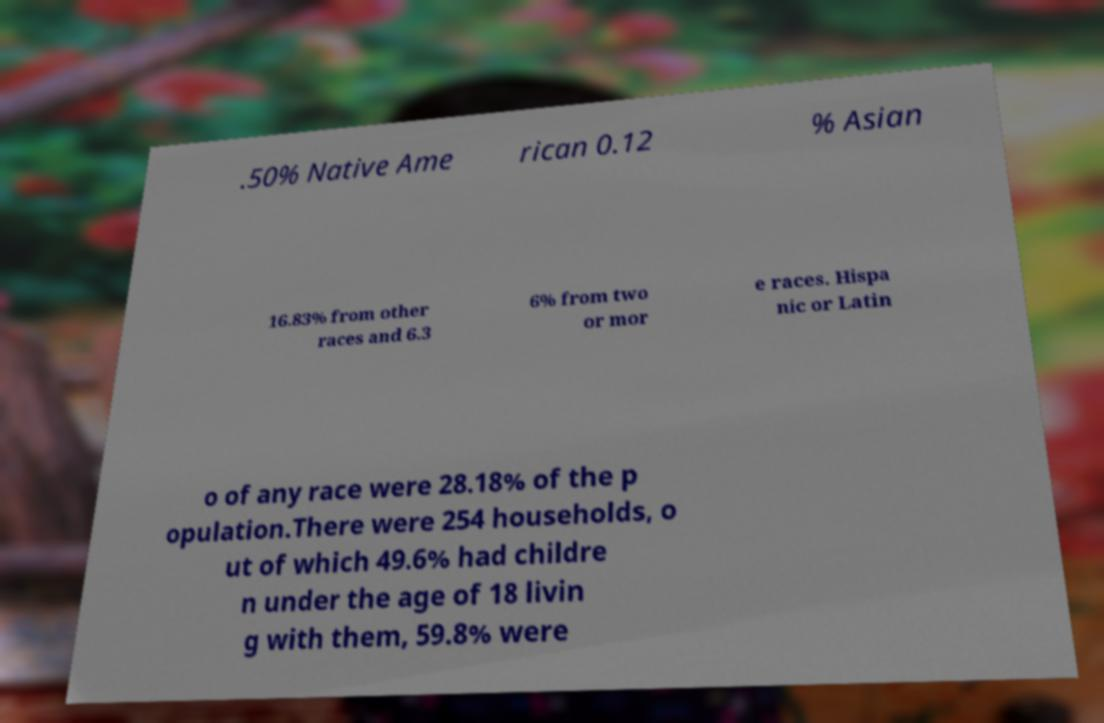Can you read and provide the text displayed in the image?This photo seems to have some interesting text. Can you extract and type it out for me? .50% Native Ame rican 0.12 % Asian 16.83% from other races and 6.3 6% from two or mor e races. Hispa nic or Latin o of any race were 28.18% of the p opulation.There were 254 households, o ut of which 49.6% had childre n under the age of 18 livin g with them, 59.8% were 